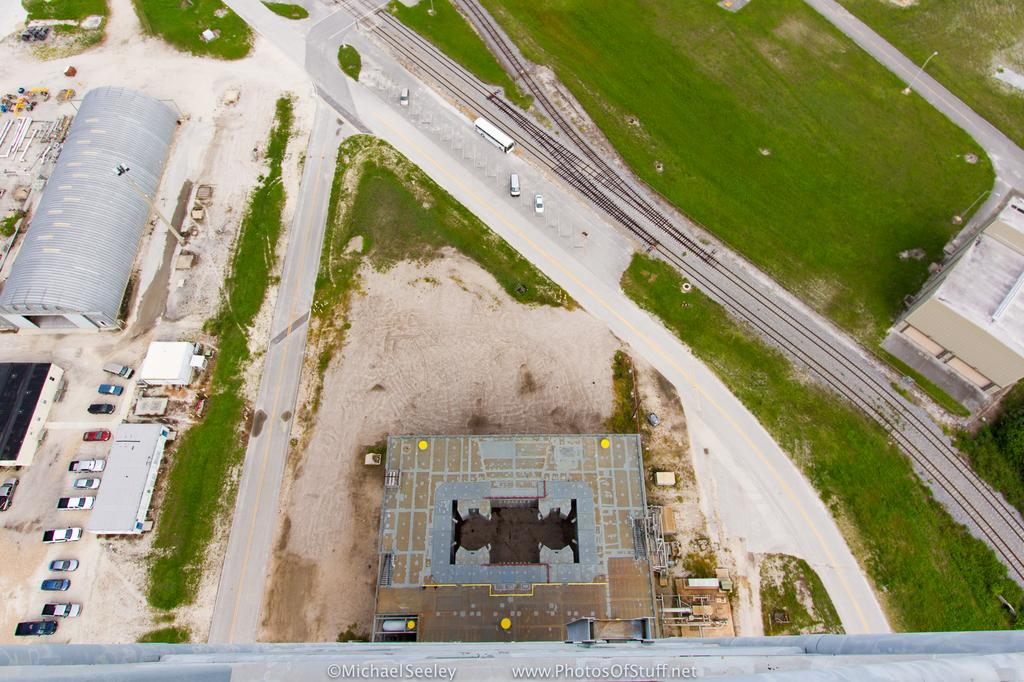What type of structures can be seen in the image? There are buildings in the image. What else is present in the image besides buildings? There are vehicles, trees, poles, and lights in the image. Can you describe the natural elements in the image? There are trees in the image. What type of infrastructure is present in the image? There are poles and lights in the image. What type of milk can be seen flowing from the faucet in the image? There is no faucet or milk present in the image. How many buns are visible on the table in the image? There is no table or buns present in the image. 